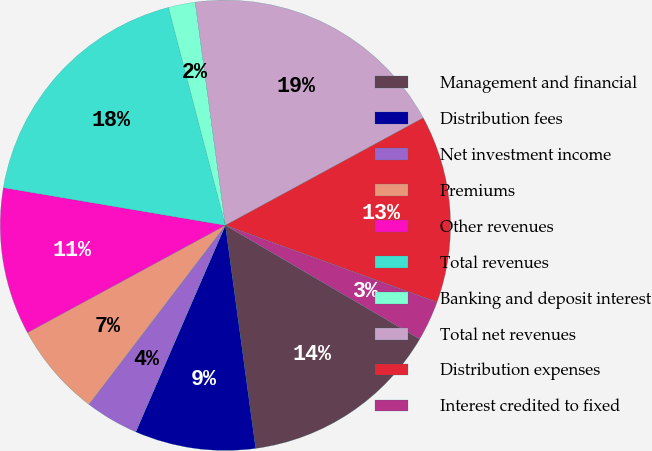Convert chart to OTSL. <chart><loc_0><loc_0><loc_500><loc_500><pie_chart><fcel>Management and financial<fcel>Distribution fees<fcel>Net investment income<fcel>Premiums<fcel>Other revenues<fcel>Total revenues<fcel>Banking and deposit interest<fcel>Total net revenues<fcel>Distribution expenses<fcel>Interest credited to fixed<nl><fcel>14.42%<fcel>8.66%<fcel>3.85%<fcel>6.73%<fcel>10.58%<fcel>18.26%<fcel>1.93%<fcel>19.22%<fcel>13.46%<fcel>2.89%<nl></chart> 